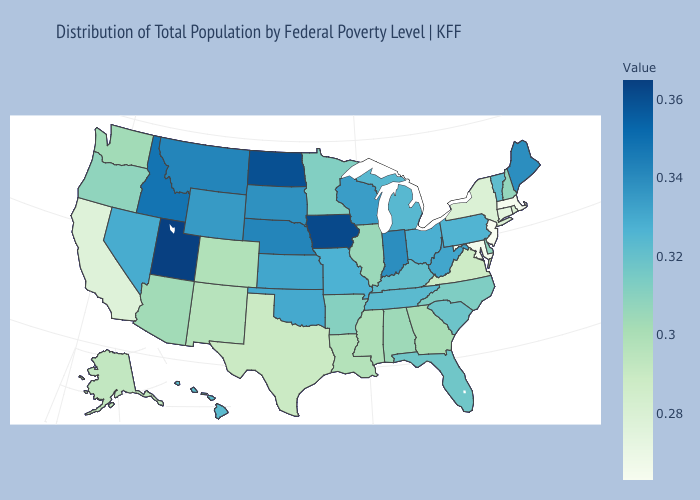Does Idaho have the highest value in the West?
Give a very brief answer. No. Among the states that border New York , does Pennsylvania have the lowest value?
Write a very short answer. No. Which states have the lowest value in the USA?
Be succinct. New Jersey. Which states have the lowest value in the USA?
Be succinct. New Jersey. 